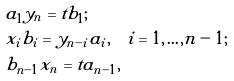Convert formula to latex. <formula><loc_0><loc_0><loc_500><loc_500>& a _ { 1 } y _ { n } = t b _ { 1 } ; \\ & x _ { i } b _ { i } = y _ { n - i } a _ { i } , \quad i = 1 , \dots , n - 1 ; \\ & b _ { n - 1 } x _ { n } = t a _ { n - 1 } ,</formula> 